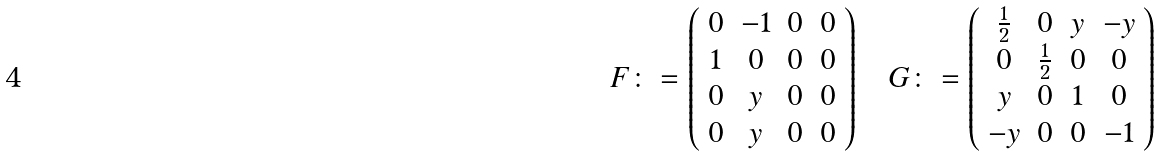<formula> <loc_0><loc_0><loc_500><loc_500>F \colon = \left ( \begin{array} { c c c c } 0 & - 1 & 0 & 0 \\ 1 & 0 & 0 & 0 \\ 0 & y & 0 & 0 \\ 0 & y & 0 & 0 \end{array} \right ) \quad G \colon = \left ( \begin{array} { c c c c } \frac { 1 } { 2 } & 0 & y & - y \\ 0 & \frac { 1 } { 2 } & 0 & 0 \\ y & 0 & 1 & 0 \\ - y & 0 & 0 & - 1 \end{array} \right )</formula> 